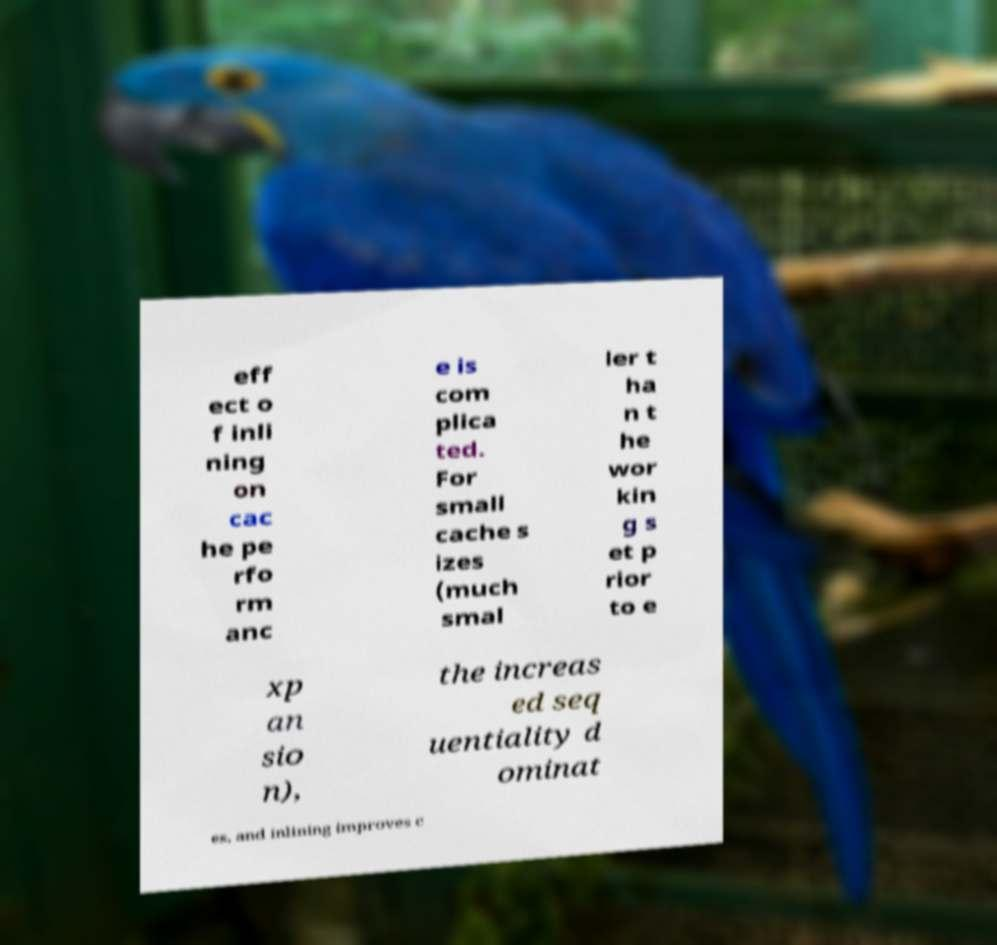There's text embedded in this image that I need extracted. Can you transcribe it verbatim? eff ect o f inli ning on cac he pe rfo rm anc e is com plica ted. For small cache s izes (much smal ler t ha n t he wor kin g s et p rior to e xp an sio n), the increas ed seq uentiality d ominat es, and inlining improves c 